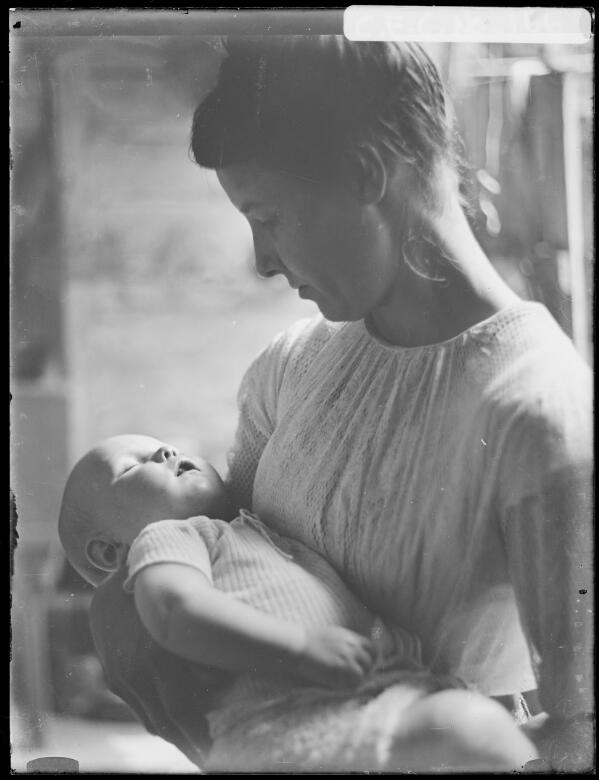Please describe the contents of this image in 5 or 6 sentences so that a person searching for it using text will be able to find it and your generated summary will provide them with an accurate description of the image. Only describe content present in the image. The image depicts a woman gently holding a sleeping baby in her arms. The woman is dressed in a light-colored, textured blouse and has her hair pulled back. She is looking down tenderly at the baby, who is dressed in a short-sleeved, light-colored outfit. The background is softly blurred, focusing attention on the subjects and giving the image an intimate and serene atmosphere. The lighting is soft and diffused, highlighting the peaceful expression on the baby's face and the nurturing demeanor of the woman. The photograph has a vintage quality, suggesting it may be from an earlier time period. 